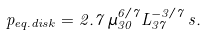<formula> <loc_0><loc_0><loc_500><loc_500>p _ { e q . d i s k } = 2 . 7 \, \mu _ { 3 0 } ^ { 6 / 7 } L _ { 3 7 } ^ { - 3 / 7 } \, s .</formula> 